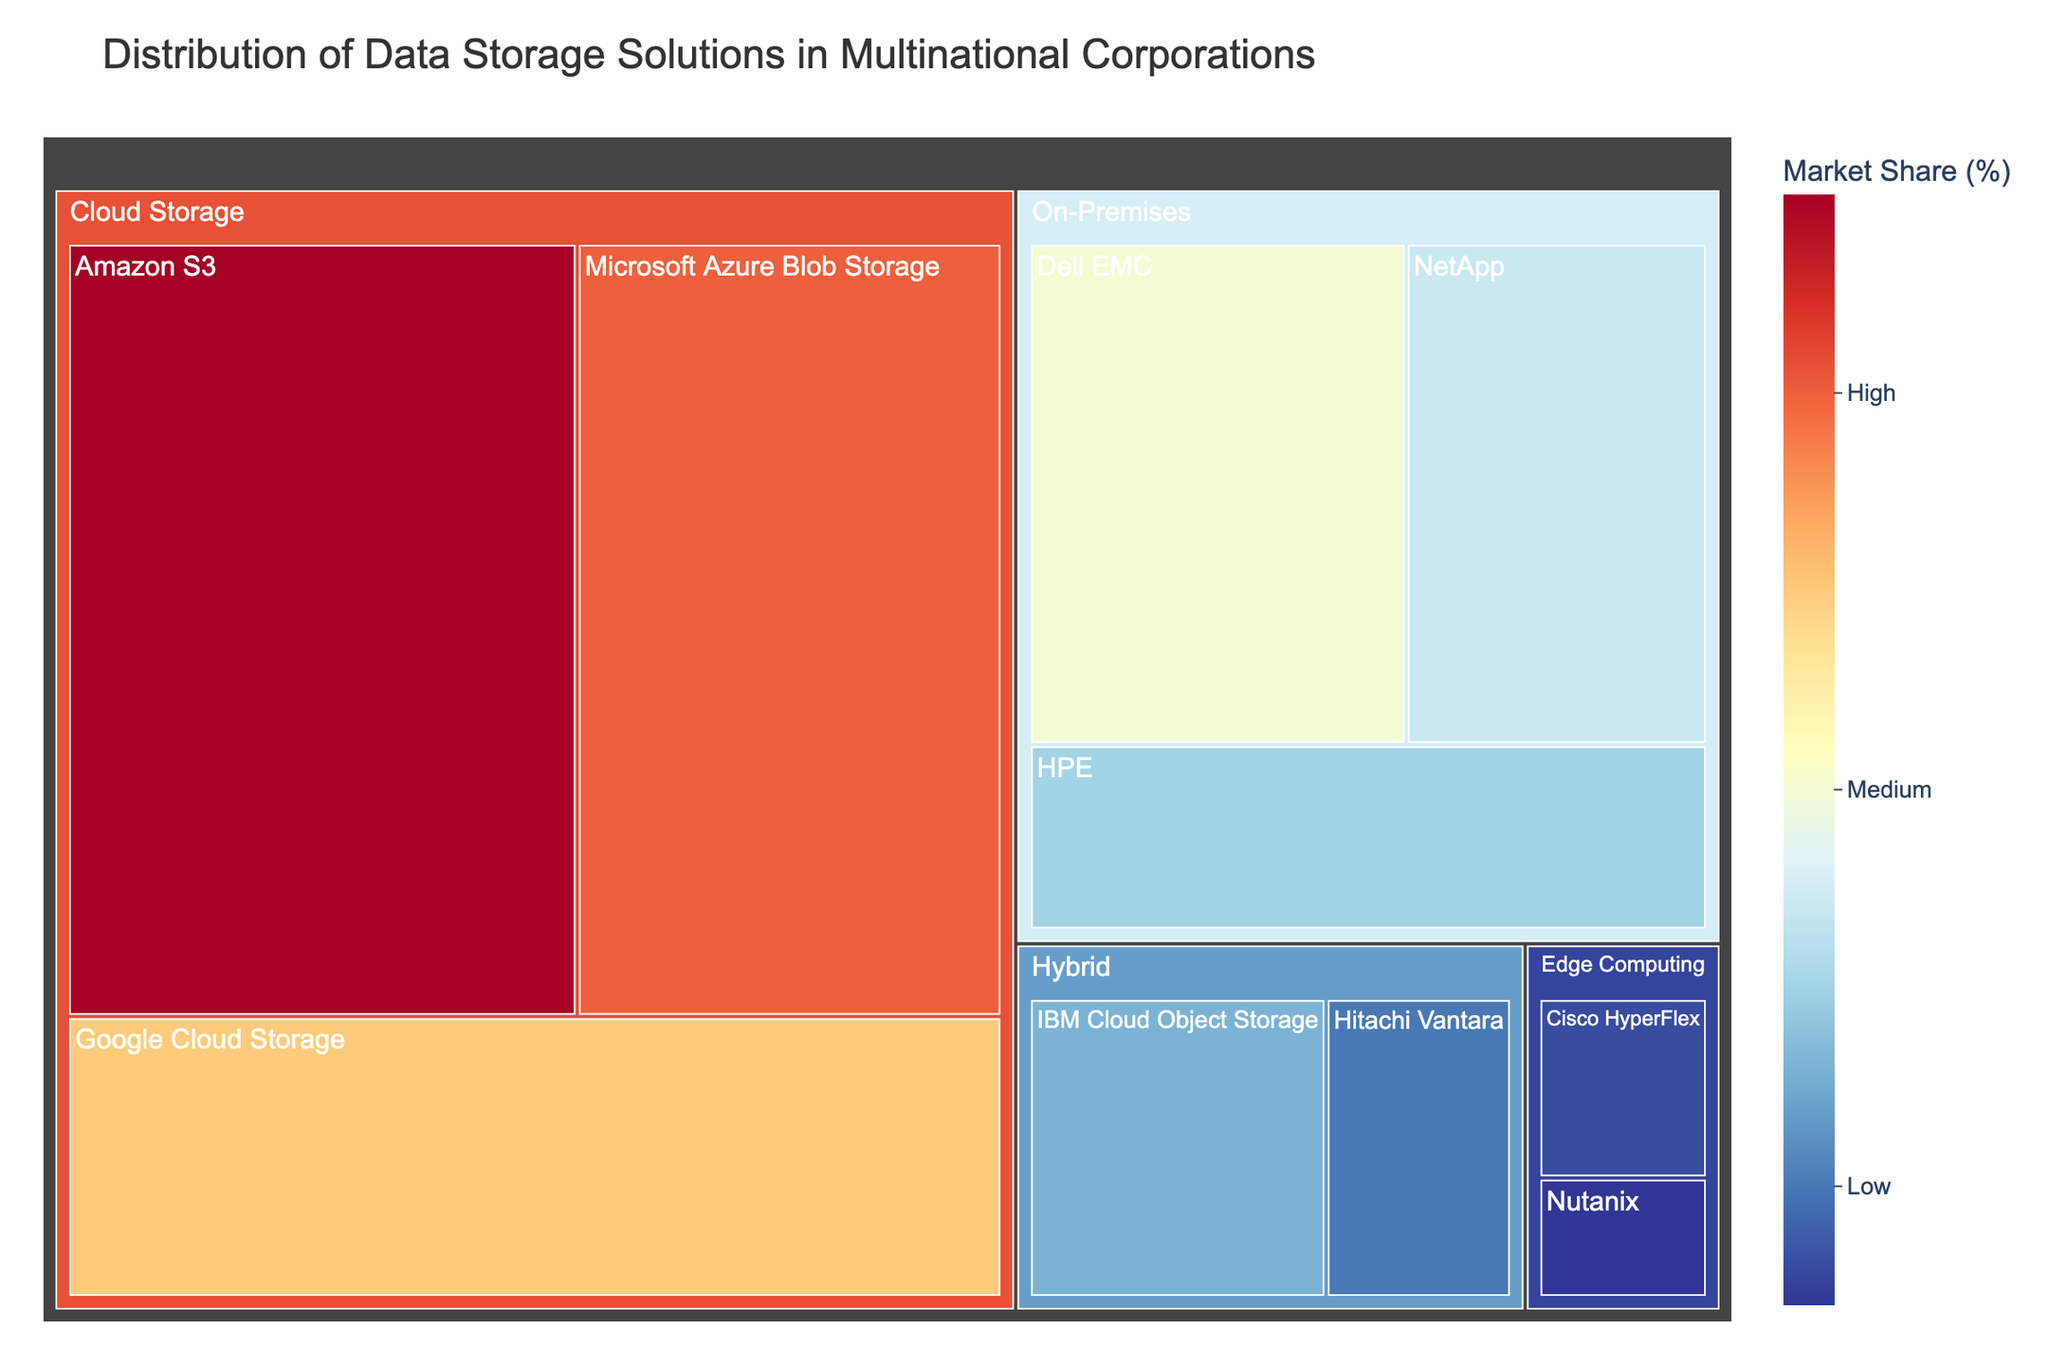What is the title of the treemap? The title of the treemap is displayed at the top of the figure.
Answer: Distribution of Data Storage Solutions in Multinational Corporations Which cloud storage solution has the highest market share? In the Cloud Storage category, the largest section belongs to Amazon S3, indicating it has the highest market share.
Answer: Amazon S3 What is the combined market share of On-Premises storage solutions? Sum the values of all On-Premises subcategories: Dell EMC (15) + NetApp (12) + HPE (10) = 37
Answer: 37 How does the market share of Google Cloud Storage compare to Microsoft Azure Blob Storage? Compare the values of Google Cloud Storage (20) and Microsoft Azure Blob Storage (25); Microsoft Azure Blob Storage has a higher value.
Answer: Microsoft Azure Blob Storage has a higher market share Which category has the smallest total market share, and what is that share? Sum the values within each category: Edge Computing (3 + 2 = 5) has the smallest total value compared to Cloud Storage (75), On-Premises (37), and Hybrid (13).
Answer: Edge Computing, 5 What is the market share difference between the top Cloud Storage solution and the top On-Premises solution? The top Cloud Storage solution is Amazon S3 (30), and the top On-Premises solution is Dell EMC (15). The difference is 30 - 15 = 15
Answer: 15 Among the Hybrid storage solutions, which has a larger market share? Compare the values of IBM Cloud Object Storage (8) and Hitachi Vantara (5); IBM Cloud Object Storage has the larger value.
Answer: IBM Cloud Object Storage What is the average market share of the Edge Computing storage solutions? There are two Edge Computing solutions: Cisco HyperFlex (3) and Nutanix (2). Their average market share is (3 + 2) / 2 = 2.5
Answer: 2.5 How many subcategories are there in total across all categories? Count all the subcategories listed in the data, which are: 2 in Edge Computing, 2 in Hybrid, 3 in On-Premises, and 3 in Cloud Storage. So, 2 + 2 + 3 + 3 = 10
Answer: 10 What's the market share of the smallest subcategory? Find the smallest value among all subcategories, which is Nutanix in Edge Computing with a value of 2.
Answer: 2 